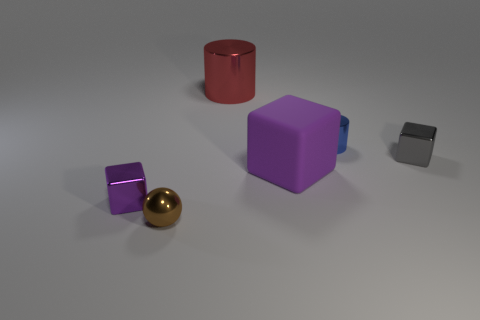Subtract all purple blocks. How many blocks are left? 1 Add 2 large shiny objects. How many objects exist? 8 Subtract all cylinders. How many objects are left? 4 Subtract all purple cubes. How many cubes are left? 1 Subtract all purple cylinders. How many purple cubes are left? 2 Subtract all yellow balls. Subtract all gray cubes. How many balls are left? 1 Subtract all small gray cubes. Subtract all tiny blocks. How many objects are left? 3 Add 6 blocks. How many blocks are left? 9 Add 5 red metal cubes. How many red metal cubes exist? 5 Subtract 0 cyan cylinders. How many objects are left? 6 